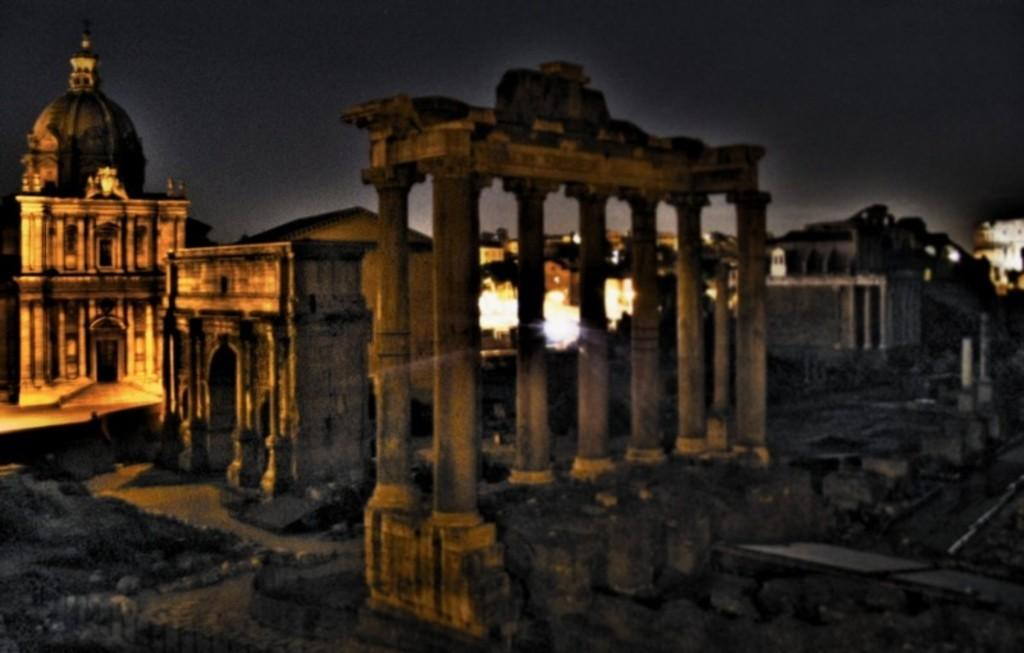What type of structures can be seen in the image? There are monuments and pillars in the image. Can you describe the monuments in the image? The provided facts do not give specific details about the monuments, so we cannot describe them further. What is the purpose of the pillars in the image? The purpose of the pillars in the image is not mentioned in the provided facts, so we cannot determine their purpose. How many servants are present in the image? There is no mention of servants in the provided facts, so we cannot determine if any are present in the image. What type of canvas is used for the monuments in the image? There is no mention of canvas in the provided facts, so we cannot determine if any is used for the monuments in the image. 